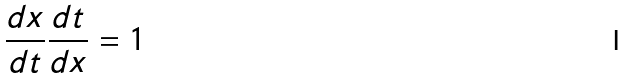<formula> <loc_0><loc_0><loc_500><loc_500>\frac { d x } { d t } \frac { d t } { d x } = 1</formula> 